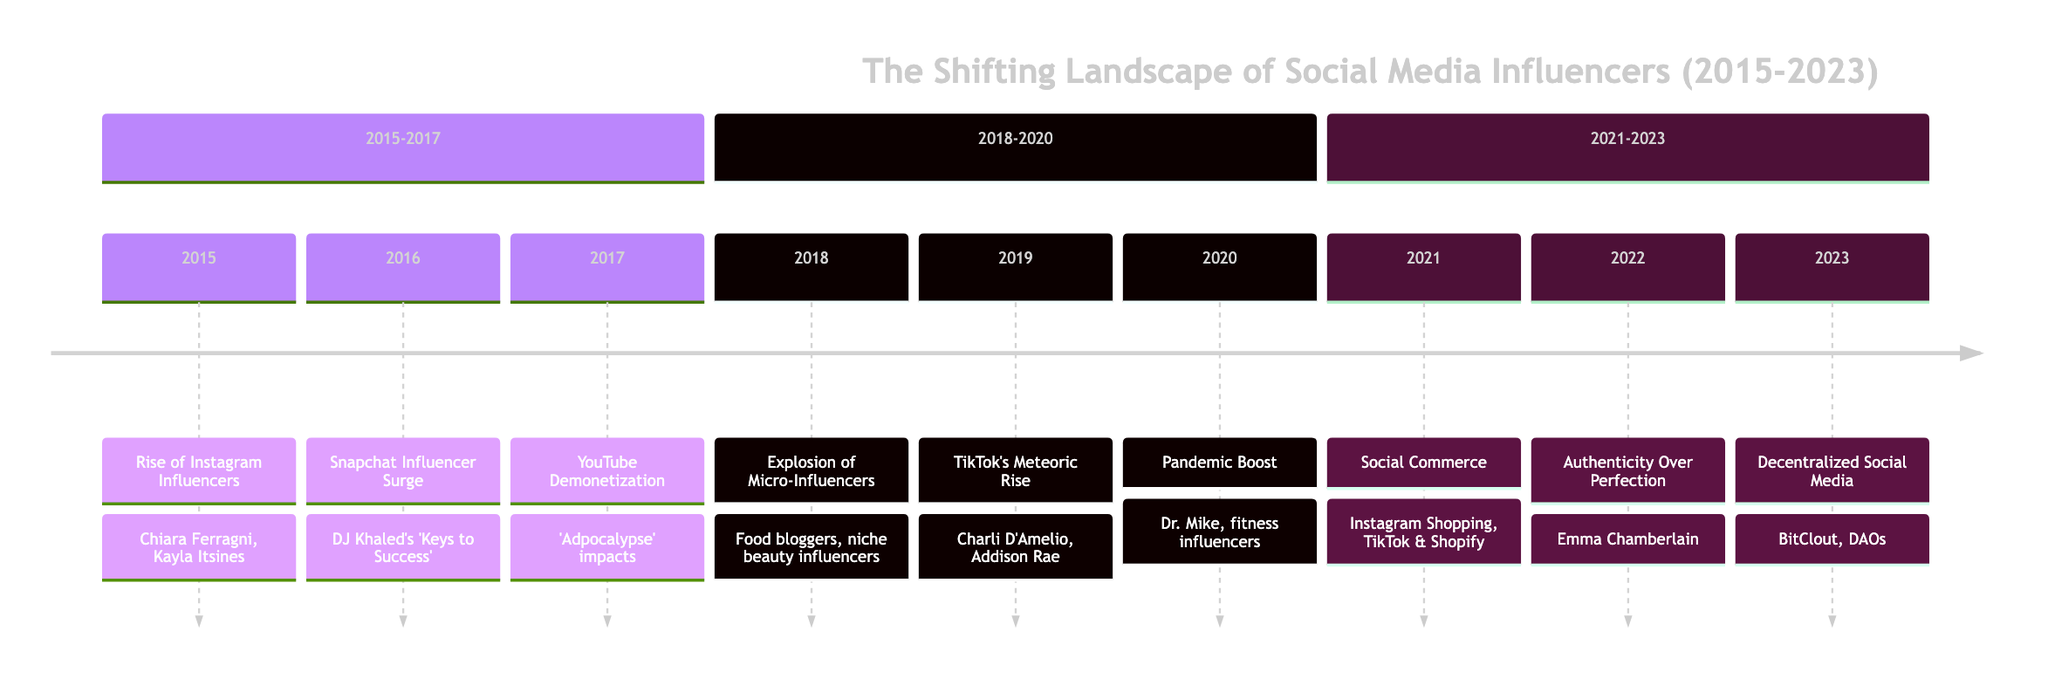What's the key event in 2019? The diagram indicates that the key event in 2019 is "TikTok's Meteoric Rise." This information is located directly under the year 2019 on the timeline.
Answer: TikTok's Meteoric Rise How many influencers are mentioned in 2015? The timeline specifically lists two influencers under the key event in 2015: Chiara Ferragni and Kayla Itsines. Therefore, we count them to find that there are two influencers mentioned.
Answer: 2 Which platform saw a significant influencer surge in 2016? Referring to the event in 2016, the diagram notes that Snapchat is the platform that gained popularity for influencers during that year.
Answer: Snapchat What trend started in 2018 regarding influencer types? The key event for 2018 highlights the "Explosion of Micro-Influencers." This phrase indicates the trend of shifting focus towards smaller influencers with 10k-100k followers, distinguishing them from mega-influencers.
Answer: Explosion of Micro-Influencers What was the major impact of YouTube's policies in 2017? The diagram states that in 2017, YouTube's new demonetization policies led to the "Adpocalypse," affecting many creators financially, thus prompting a pivot towards alternative revenue streams.
Answer: Adpocalypse How did social media change due to the pandemic in 2020? According to the timeline section for 2020, the pandemic boosted social media usage as influencers became key channels for entertainment and information during lockdowns. This indicates a significant shift in the role of influencers on social media.
Answer: Pandemic Boost What connection can be observed between 2021 and 2022 regarding content style? The event in 2021 discusses the rise of social commerce, while 2022 focuses on "Authenticity Over Perfection." It can be reasoned that the emphasis on shopping unfiltered, authentic content in 2022 could be a response to the commercial overtone established in 2021.
Answer: Authenticity Over Perfection Which year marks the emergence of decentralized social media? In 2023, the timeline states the key event is "Decentralized Social Media," which indicates the introduction of new platforms and technologies for creators. Thus, 2023 is the year noted for this development.
Answer: 2023 Which influencer is noted for providing medical advice during the pandemic? The entry for 2020 mentions Dr. Mike as an influencer who gained popularity by offering medical advice during the COVID-19 lockdown, indicating his impact during that year.
Answer: Dr. Mike 